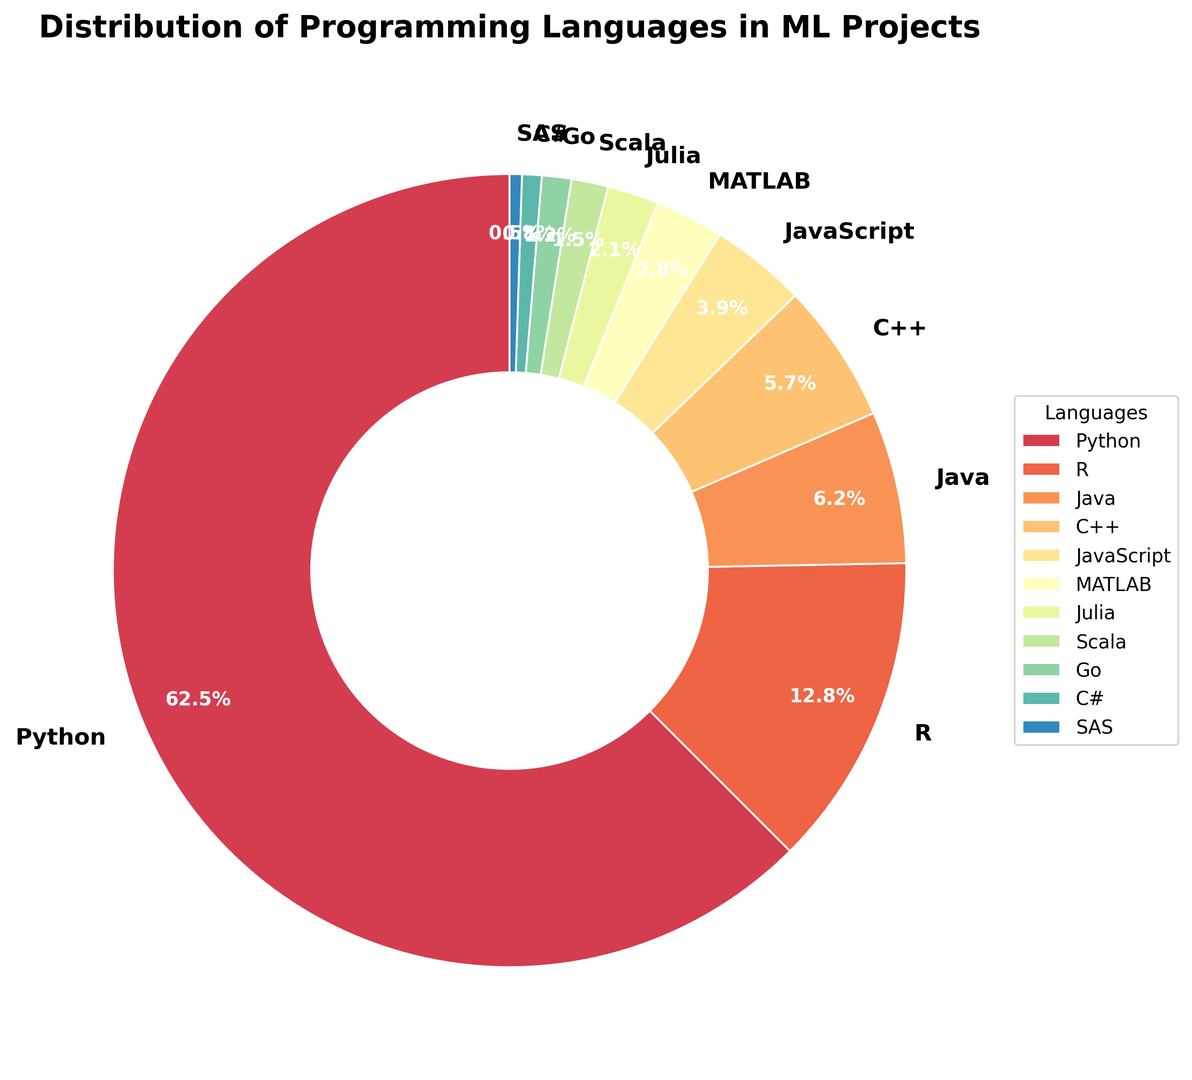What is the most commonly used programming language in machine learning projects? The figure shows the distribution of programming languages used in ML projects. The largest segment is for Python, indicating it is the most commonly used language.
Answer: Python What is the combined percentage of Python and R use in ML projects? Add the percentage values of Python and R: 62.5% (Python) + 12.8% (R) = 75.3%.
Answer: 75.3% Which language has a larger share, JavaScript or MATLAB? Compare the percentages of JavaScript (3.9%) and MATLAB (2.8%).
Answer: JavaScript Is the usage of C++ higher or lower than Java? Compare the percentages of C++ (5.7%) and Java (6.2%).
Answer: Lower What is the percentage difference between the usage of Python and Java in ML projects? Subtract the percentage of Java (6.2%) from Python (62.5%): 62.5% - 6.2% = 56.3%.
Answer: 56.3% How many languages have a usage percentage below 2%? Identify the languages with percentages below 2%: Julia (2.1%), Scala (1.5%), Go (1.2%), C# (0.8%), SAS (0.5%). Count these languages: 4.
Answer: 4 What is the total percentage of usage for the languages that have a pie chart segment in green color? Visualize the pie chart and identify the segments in green color. Sum their percentages.
Answer: Varies by exact colors used Which programming language has the smallest usage percentage? Locate the smallest segment in the pie chart, which corresponds to SAS at 0.5%.
Answer: SAS What is the visual difference between the wedges representing Python and C#? Python (62.5%) will have a much larger wedge compared to C# (0.8%).
Answer: Python's wedge is much larger If you were to remove Python from this distribution, which language would have the highest percentage of use in ML projects? Without Python, the largest remaining segment is R, at 12.8%.
Answer: R 